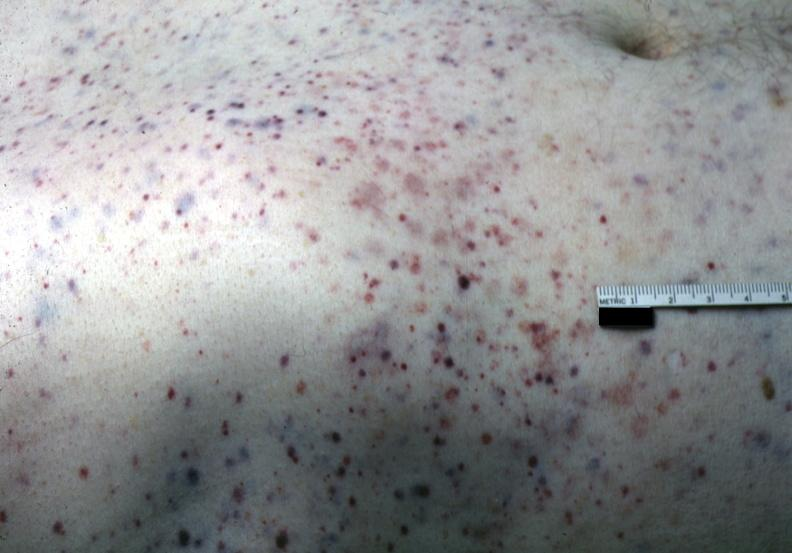what does this image show?
Answer the question using a single word or phrase. White skin with multiple lesions 